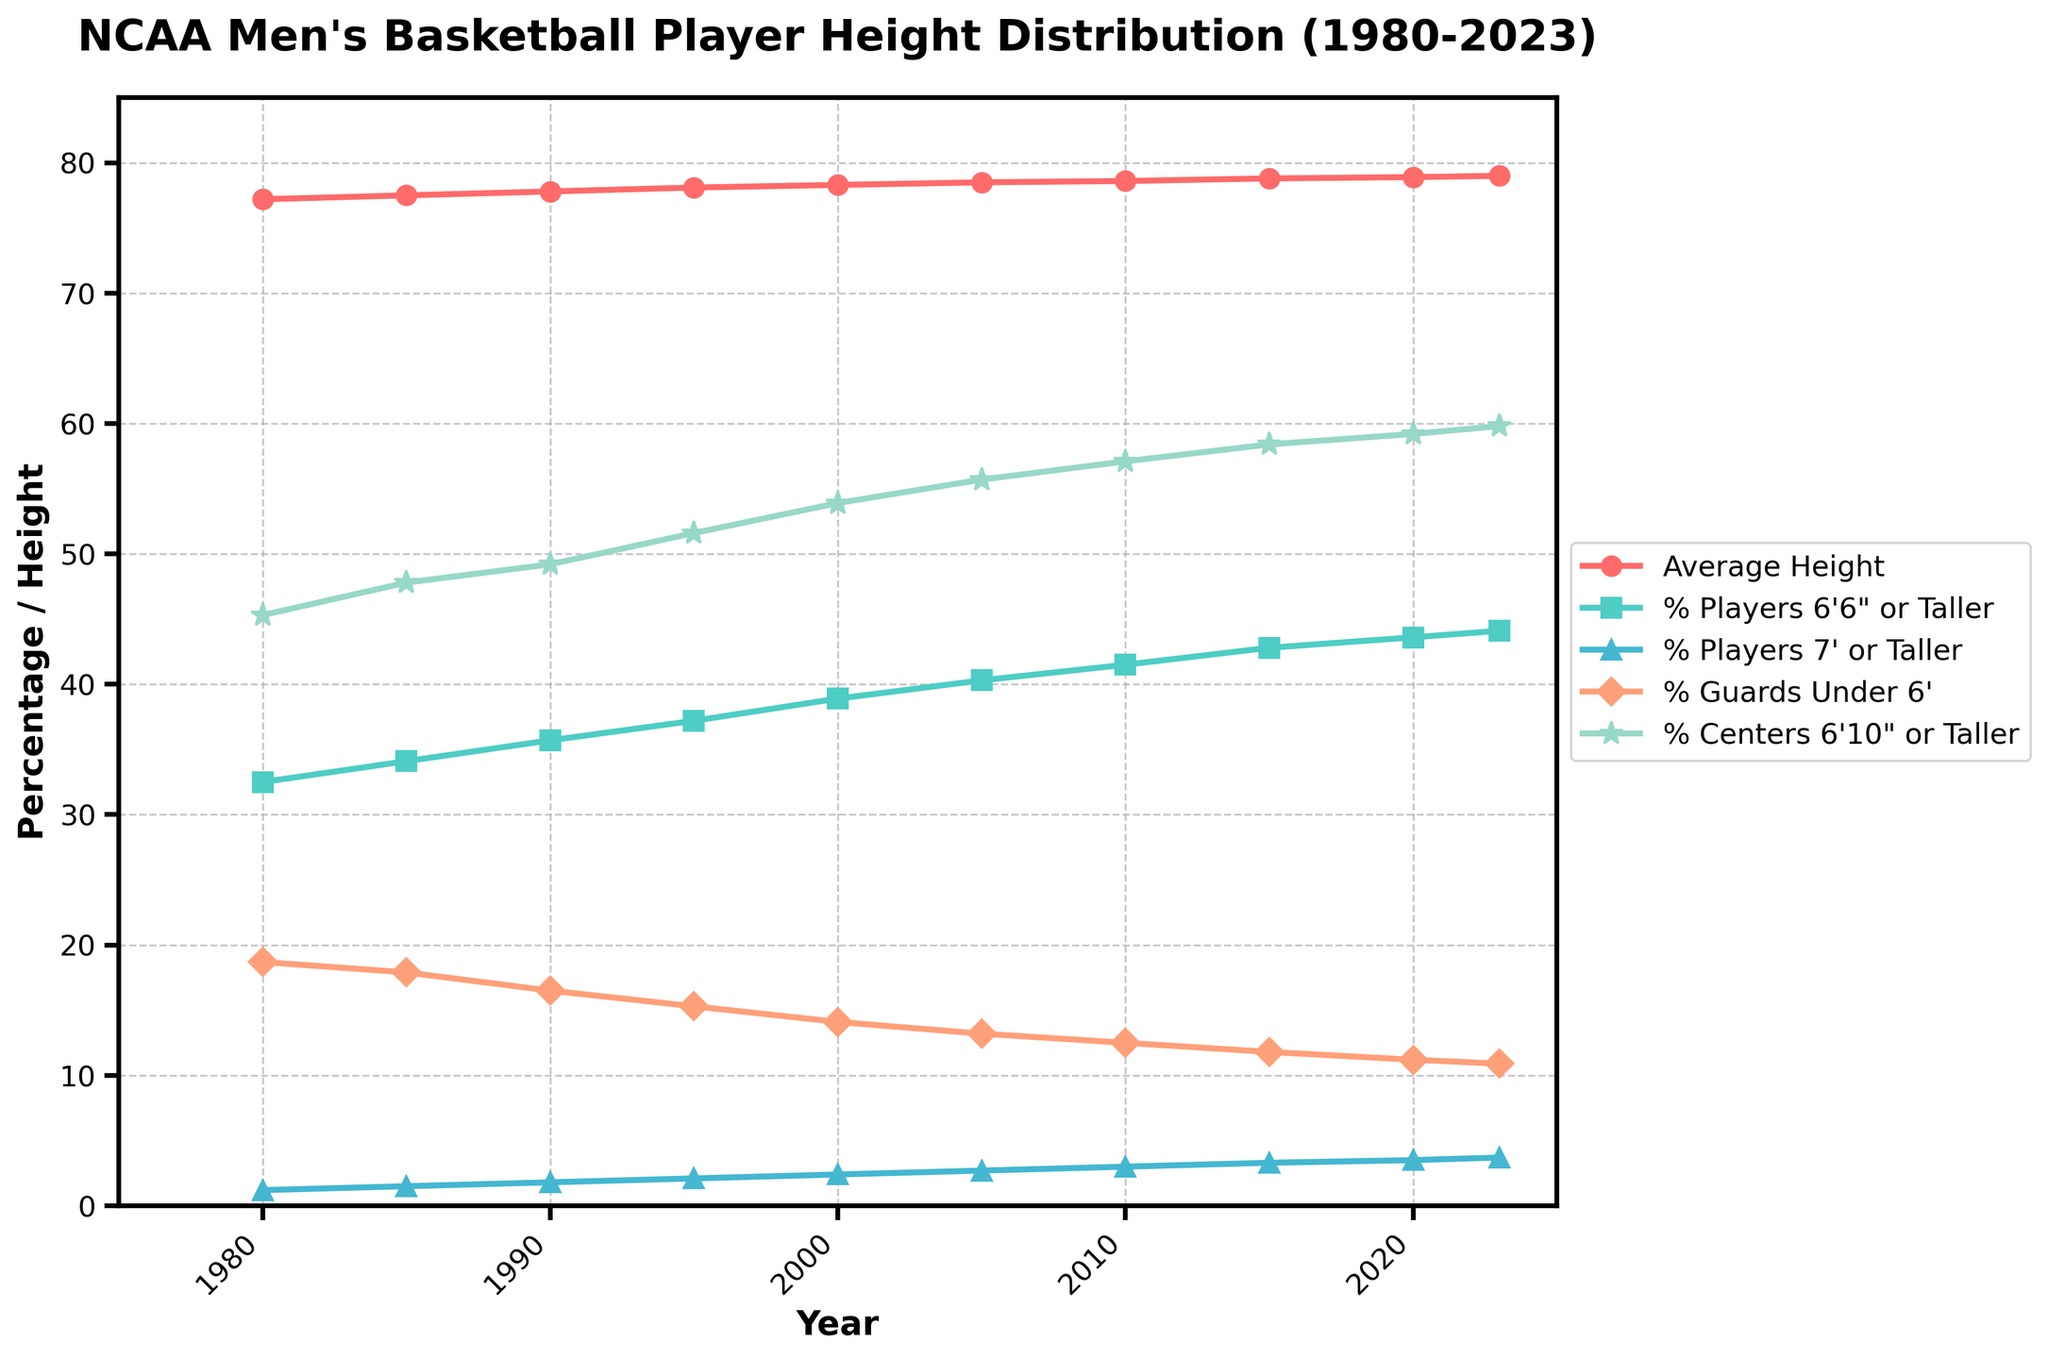What is the general trend of the average height of NCAA men's basketball players from 1980 to 2023? The plot of the "Average Height" shows an upward trend from 1980 to 2023, indicating that the average height of players has increased. Starting at 77.2 inches in 1980, it rises to 79.0 inches in 2023.
Answer: Increasing Which year shows the highest percentage of players who are 6'6" or taller? By examining the "% Players 6'6\" or Taller" line, we see the highest point occurs in 2023 with a value of 44.1%.
Answer: 2023 How has the percentage of guards under 6' changed from 1980 to 2023? The "% Guards Under 6'" line shows a general downward trend from 1980 to 2023. It starts at 18.7% in 1980 and decreases to 10.9% in 2023, indicating a reduction.
Answer: Decreased Between 2000 and 2023, what is the difference in the percentage of centers that are 6'10" or taller? In 2000, the percentage for "% Centers 6'10\" or Taller" is 53.9%, and in 2023, it is 59.8%. The difference is 59.8% - 53.9% = 5.9%.
Answer: 5.9% In which year did the percentage of players who are 7' or taller cross 3% for the first time? On observing the "% Players 7' or Taller" line, we see it crosses 3% between 2005 and 2010. These values are 2.7% in 2005 and 3.0% in 2010. Thus, it crossed 3% in 2010.
Answer: 2010 Compare the average height and the percentage of players 6'6" or taller in 1990. Which one had a greater increase rate since 1980? From 1980 to 1990, the average height increased from 77.2 inches to 77.8 inches (a difference of 0.6 inches), while the percentage of players 6'6" or taller increased from 32.5% to 35.7% (a difference of 3.2%). The percentage of players 6'6" or taller had a greater increase rate.
Answer: % Players 6'6" or Taller Is there any year where both the average height and the percentage of guards under 6' simultaneously reached their minimum values between 1980 and 2023? By looking at both the "Average Height" and "% Guards Under 6'" lines, the minimum value for average height is in 1980 (77.2 inches) and the minimum for guards under 6' is in 2023 (10.9%). There is no year where both reached their minimum simultaneously.
Answer: No 